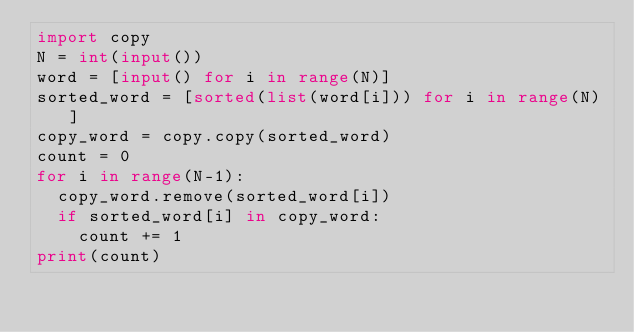Convert code to text. <code><loc_0><loc_0><loc_500><loc_500><_Python_>import copy
N = int(input())
word = [input() for i in range(N)]
sorted_word = [sorted(list(word[i])) for i in range(N)]
copy_word = copy.copy(sorted_word)
count = 0
for i in range(N-1):
  copy_word.remove(sorted_word[i])
  if sorted_word[i] in copy_word:
    count += 1
print(count)
</code> 